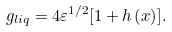<formula> <loc_0><loc_0><loc_500><loc_500>g _ { l i q } = 4 \varepsilon ^ { 1 / 2 } [ 1 + h \left ( x \right ) ] .</formula> 